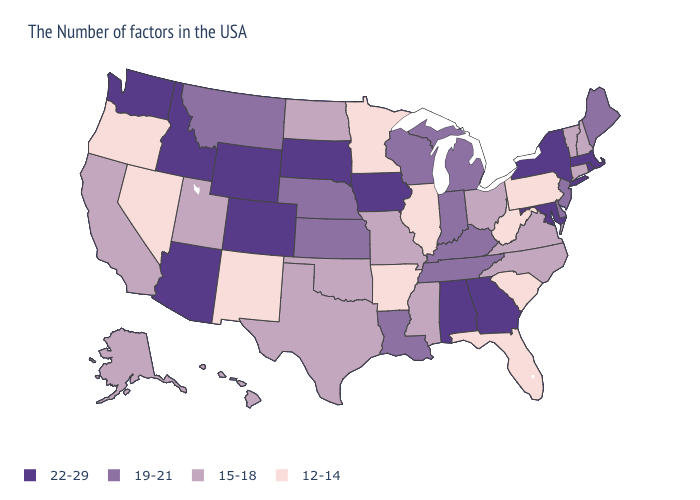Does South Dakota have the highest value in the USA?
Be succinct. Yes. Does the map have missing data?
Concise answer only. No. Does the map have missing data?
Concise answer only. No. What is the value of Missouri?
Be succinct. 15-18. Name the states that have a value in the range 22-29?
Quick response, please. Massachusetts, Rhode Island, New York, Maryland, Georgia, Alabama, Iowa, South Dakota, Wyoming, Colorado, Arizona, Idaho, Washington. Name the states that have a value in the range 15-18?
Answer briefly. New Hampshire, Vermont, Connecticut, Virginia, North Carolina, Ohio, Mississippi, Missouri, Oklahoma, Texas, North Dakota, Utah, California, Alaska, Hawaii. What is the value of Rhode Island?
Short answer required. 22-29. Which states have the highest value in the USA?
Quick response, please. Massachusetts, Rhode Island, New York, Maryland, Georgia, Alabama, Iowa, South Dakota, Wyoming, Colorado, Arizona, Idaho, Washington. What is the highest value in the USA?
Give a very brief answer. 22-29. What is the value of Hawaii?
Give a very brief answer. 15-18. Does Colorado have the highest value in the USA?
Keep it brief. Yes. What is the value of Mississippi?
Short answer required. 15-18. Does Idaho have the lowest value in the West?
Write a very short answer. No. What is the highest value in the USA?
Quick response, please. 22-29. What is the value of North Dakota?
Answer briefly. 15-18. 